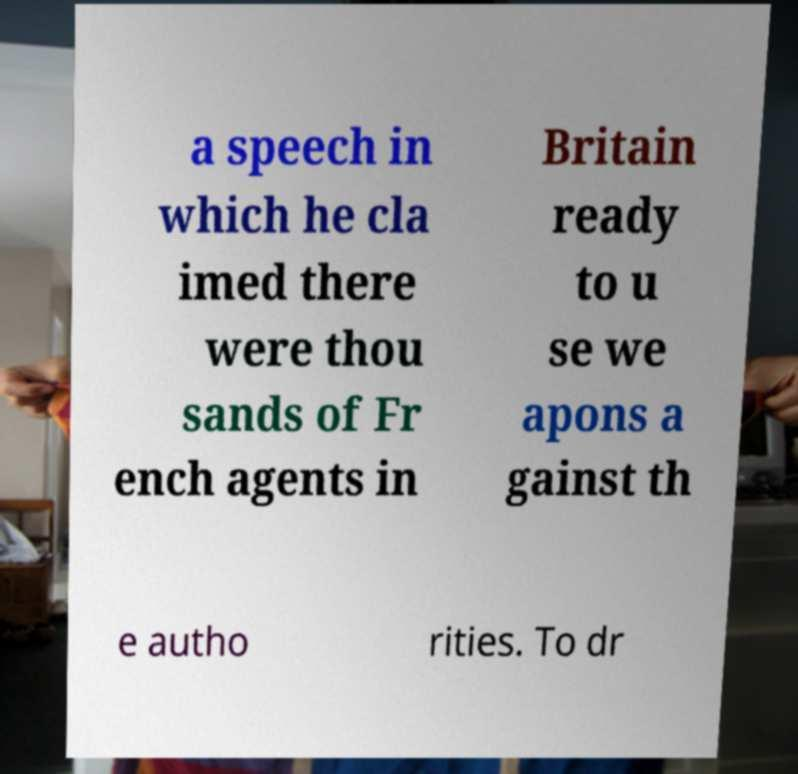There's text embedded in this image that I need extracted. Can you transcribe it verbatim? a speech in which he cla imed there were thou sands of Fr ench agents in Britain ready to u se we apons a gainst th e autho rities. To dr 